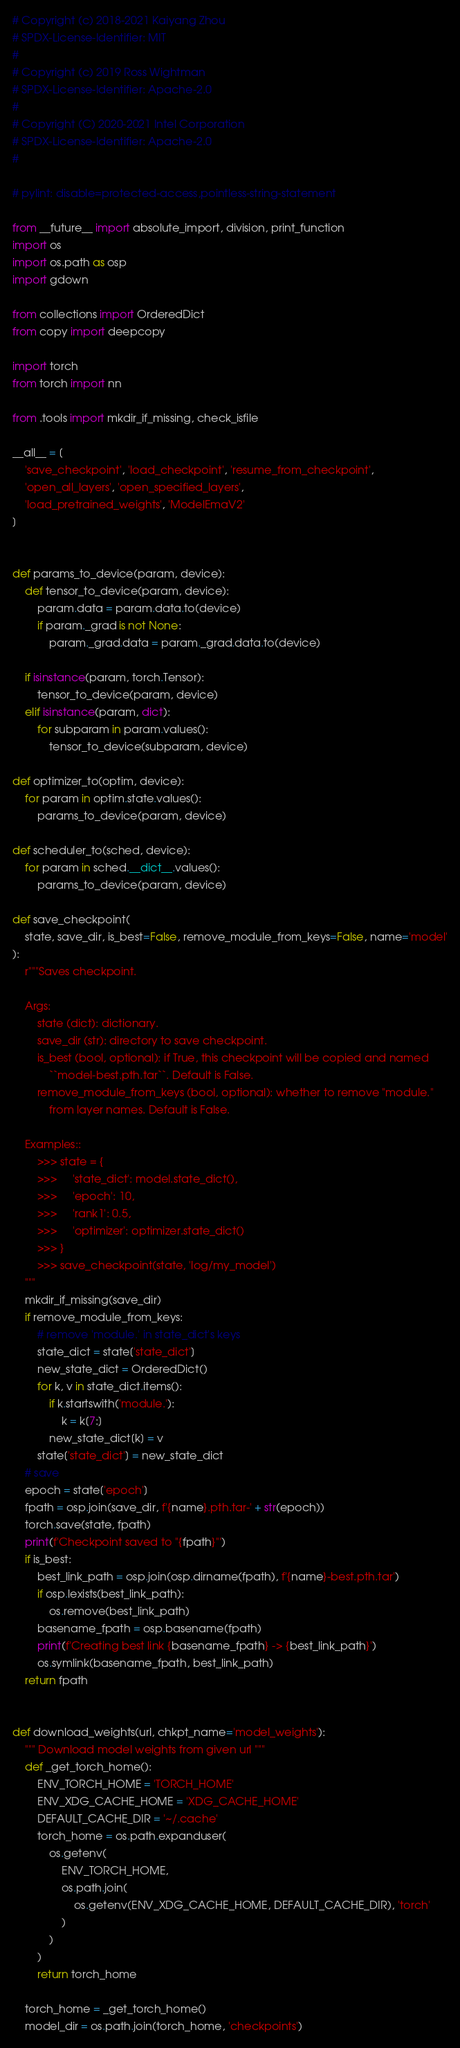Convert code to text. <code><loc_0><loc_0><loc_500><loc_500><_Python_># Copyright (c) 2018-2021 Kaiyang Zhou
# SPDX-License-Identifier: MIT
#
# Copyright (c) 2019 Ross Wightman
# SPDX-License-Identifier: Apache-2.0
#
# Copyright (C) 2020-2021 Intel Corporation
# SPDX-License-Identifier: Apache-2.0
#

# pylint: disable=protected-access,pointless-string-statement

from __future__ import absolute_import, division, print_function
import os
import os.path as osp
import gdown

from collections import OrderedDict
from copy import deepcopy

import torch
from torch import nn

from .tools import mkdir_if_missing, check_isfile

__all__ = [
    'save_checkpoint', 'load_checkpoint', 'resume_from_checkpoint',
    'open_all_layers', 'open_specified_layers',
    'load_pretrained_weights', 'ModelEmaV2'
]


def params_to_device(param, device):
    def tensor_to_device(param, device):
        param.data = param.data.to(device)
        if param._grad is not None:
            param._grad.data = param._grad.data.to(device)

    if isinstance(param, torch.Tensor):
        tensor_to_device(param, device)
    elif isinstance(param, dict):
        for subparam in param.values():
            tensor_to_device(subparam, device)

def optimizer_to(optim, device):
    for param in optim.state.values():
        params_to_device(param, device)

def scheduler_to(sched, device):
    for param in sched.__dict__.values():
        params_to_device(param, device)

def save_checkpoint(
    state, save_dir, is_best=False, remove_module_from_keys=False, name='model'
):
    r"""Saves checkpoint.

    Args:
        state (dict): dictionary.
        save_dir (str): directory to save checkpoint.
        is_best (bool, optional): if True, this checkpoint will be copied and named
            ``model-best.pth.tar``. Default is False.
        remove_module_from_keys (bool, optional): whether to remove "module."
            from layer names. Default is False.

    Examples::
        >>> state = {
        >>>     'state_dict': model.state_dict(),
        >>>     'epoch': 10,
        >>>     'rank1': 0.5,
        >>>     'optimizer': optimizer.state_dict()
        >>> }
        >>> save_checkpoint(state, 'log/my_model')
    """
    mkdir_if_missing(save_dir)
    if remove_module_from_keys:
        # remove 'module.' in state_dict's keys
        state_dict = state['state_dict']
        new_state_dict = OrderedDict()
        for k, v in state_dict.items():
            if k.startswith('module.'):
                k = k[7:]
            new_state_dict[k] = v
        state['state_dict'] = new_state_dict
    # save
    epoch = state['epoch']
    fpath = osp.join(save_dir, f'{name}.pth.tar-' + str(epoch))
    torch.save(state, fpath)
    print(f'Checkpoint saved to "{fpath}"')
    if is_best:
        best_link_path = osp.join(osp.dirname(fpath), f'{name}-best.pth.tar')
        if osp.lexists(best_link_path):
            os.remove(best_link_path)
        basename_fpath = osp.basename(fpath)
        print(f'Creating best link {basename_fpath} -> {best_link_path}')
        os.symlink(basename_fpath, best_link_path)
    return fpath


def download_weights(url, chkpt_name='model_weights'):
    """ Download model weights from given url """
    def _get_torch_home():
        ENV_TORCH_HOME = 'TORCH_HOME'
        ENV_XDG_CACHE_HOME = 'XDG_CACHE_HOME'
        DEFAULT_CACHE_DIR = '~/.cache'
        torch_home = os.path.expanduser(
            os.getenv(
                ENV_TORCH_HOME,
                os.path.join(
                    os.getenv(ENV_XDG_CACHE_HOME, DEFAULT_CACHE_DIR), 'torch'
                )
            )
        )
        return torch_home

    torch_home = _get_torch_home()
    model_dir = os.path.join(torch_home, 'checkpoints')</code> 